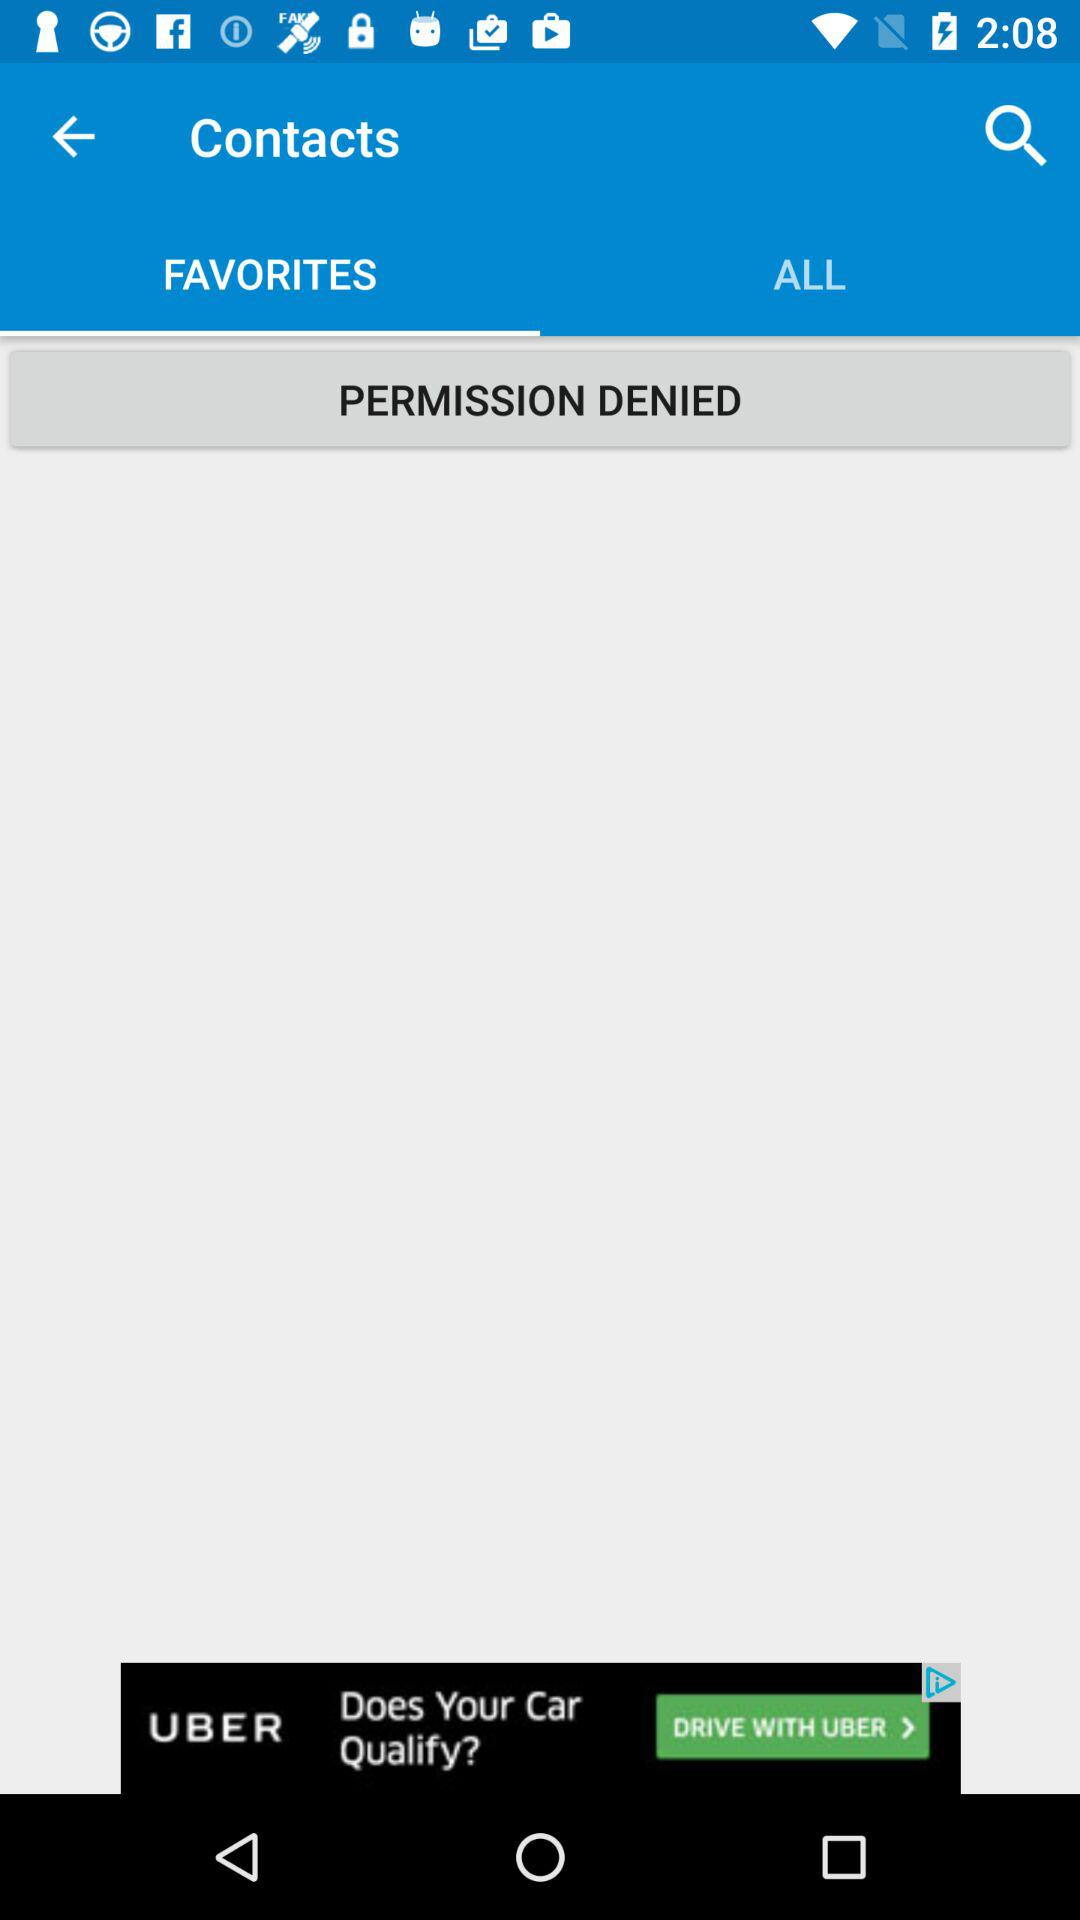Which is the selected tab? The selected tab is "FAVORITES". 